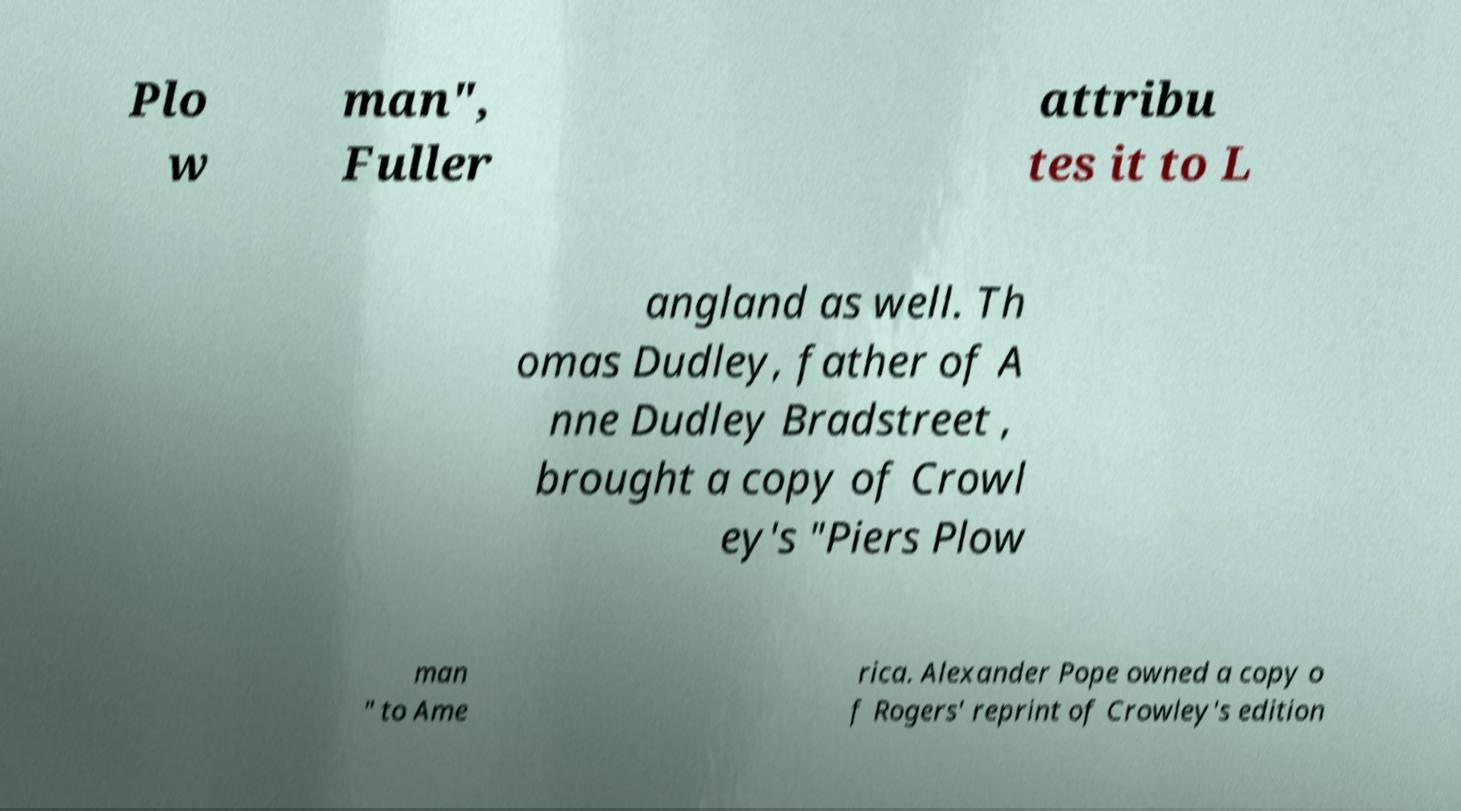There's text embedded in this image that I need extracted. Can you transcribe it verbatim? Plo w man", Fuller attribu tes it to L angland as well. Th omas Dudley, father of A nne Dudley Bradstreet , brought a copy of Crowl ey's "Piers Plow man " to Ame rica. Alexander Pope owned a copy o f Rogers' reprint of Crowley's edition 